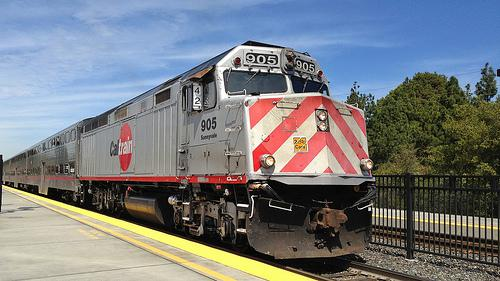Question: how many people at the platform?
Choices:
A. Four.
B. One.
C. Three.
D. Zero.
Answer with the letter. Answer: D Question: what is on the train tracks?
Choices:
A. A penny.
B. A spike.
C. A train.
D. Gravel.
Answer with the letter. Answer: C Question: what is the color of the fence?
Choices:
A. White.
B. Brown.
C. Black.
D. Red.
Answer with the letter. Answer: C Question: where is the train?
Choices:
A. At the depot.
B. In the train tracks.
C. The museum.
D. Zoo.
Answer with the letter. Answer: B Question: what is the color of the sky?
Choices:
A. Blue.
B. Gray.
C. White.
D. Pink.
Answer with the letter. Answer: A 